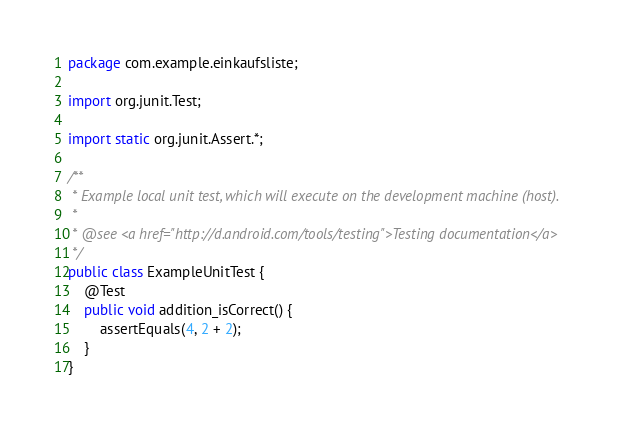<code> <loc_0><loc_0><loc_500><loc_500><_Java_>package com.example.einkaufsliste;

import org.junit.Test;

import static org.junit.Assert.*;

/**
 * Example local unit test, which will execute on the development machine (host).
 *
 * @see <a href="http://d.android.com/tools/testing">Testing documentation</a>
 */
public class ExampleUnitTest {
    @Test
    public void addition_isCorrect() {
        assertEquals(4, 2 + 2);
    }
}</code> 